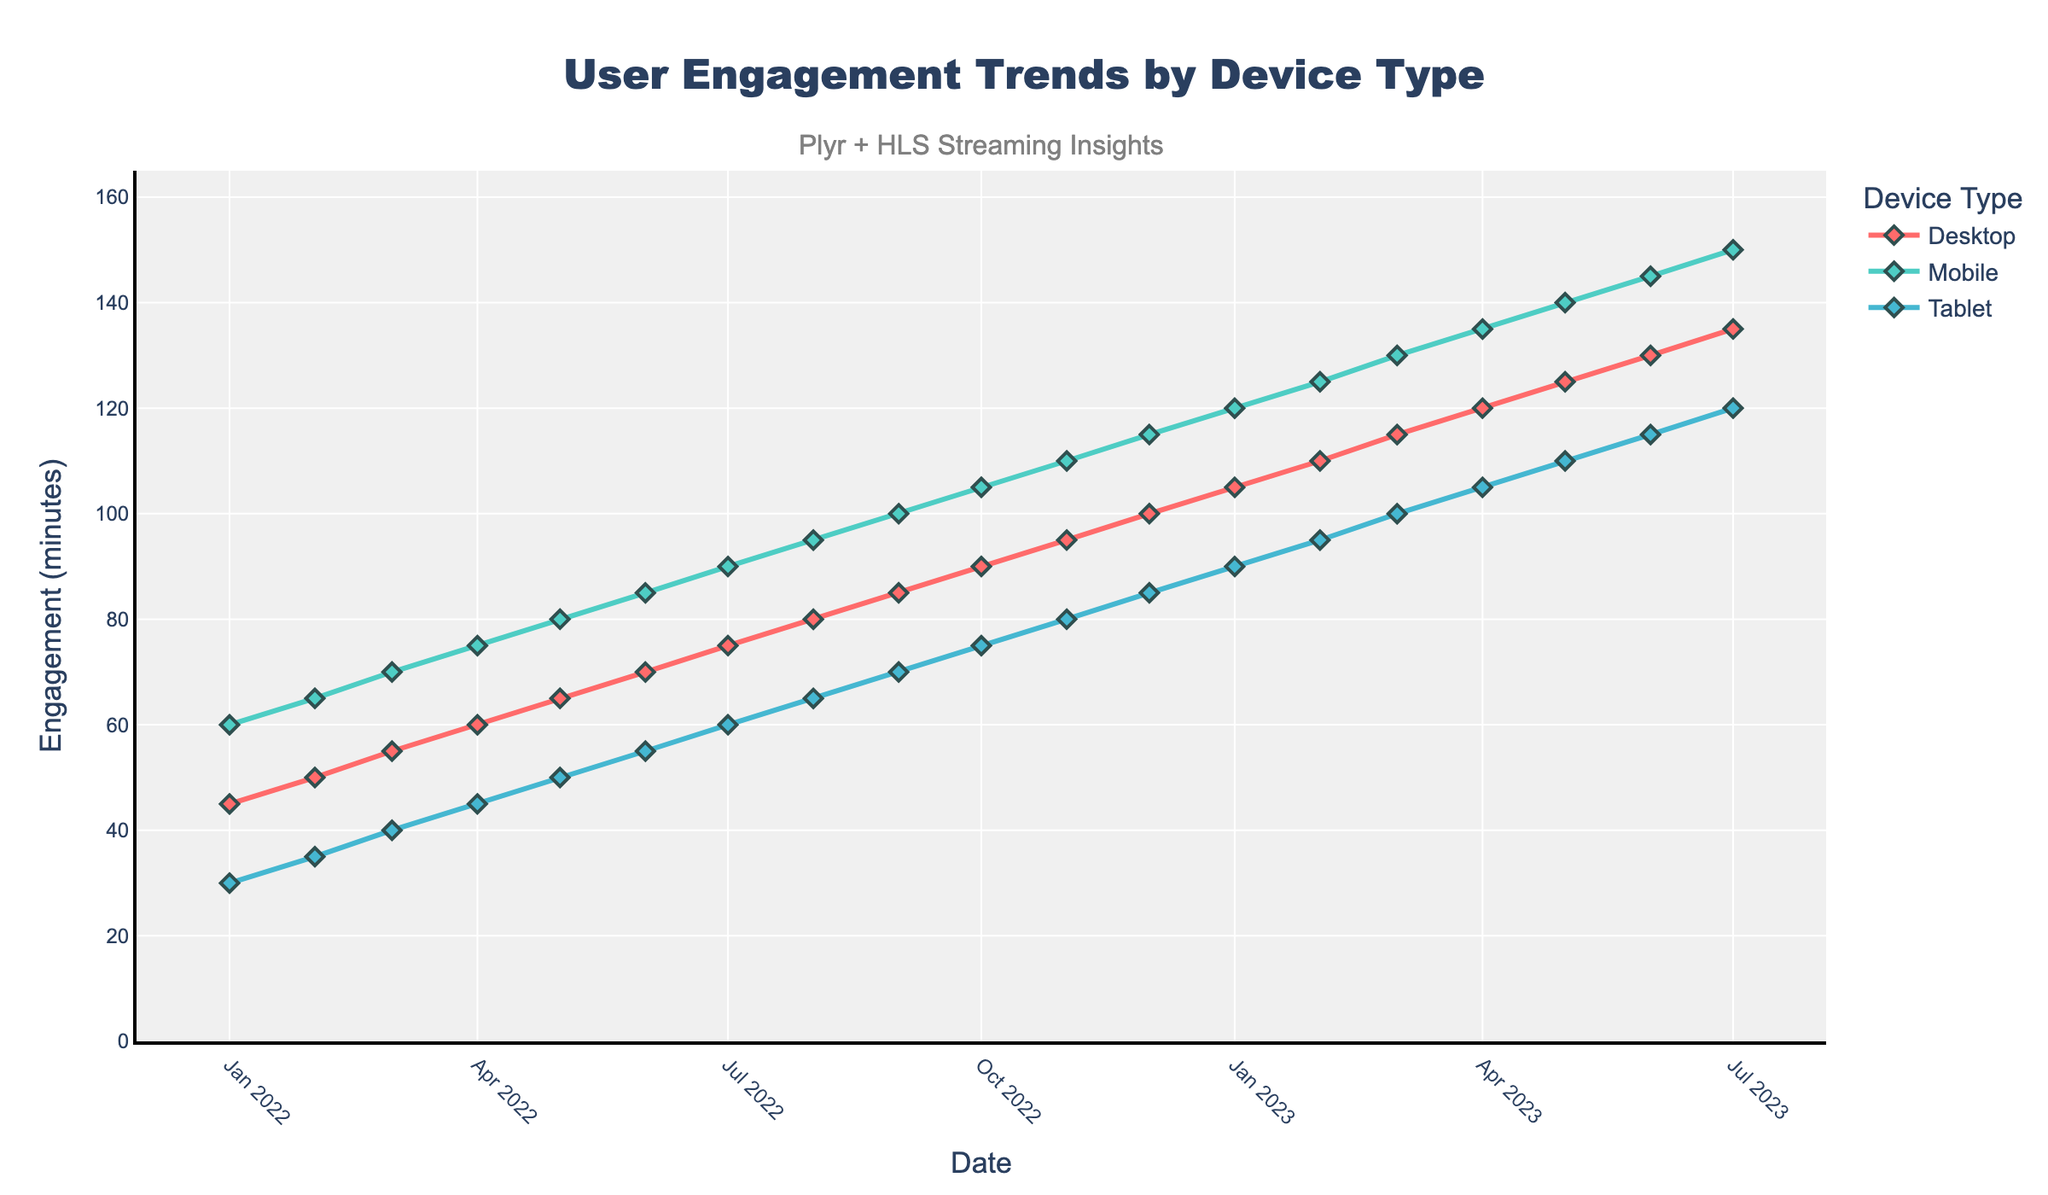What is the title of the plot? The title is displayed at the top of the plot in large, bold text. According to the title section, it reads: 'User Engagement Trends by Device Type'.
Answer: User Engagement Trends by Device Type What does the y-axis represent? The label on the y-axis states 'Engagement (minutes)', indicating that it measures engagement in minutes.
Answer: Engagement (minutes) Which device type shows the highest engagement in July 2023? By looking at the data points for July 2023, the green line representing the mobile device shows the highest engagement, stacking at around 150 minutes.
Answer: Mobile How does the engagement trend for 'tablet' change from January 2022 to July 2023? From January 2022 to July 2023, the blue line for the tablet steadily increases. It starts at 30 minutes in January 2022 and continuously rises to 120 minutes in July 2023.
Answer: Increases steadily What is the average engagement for desktop devices in the year 2022? Summing up the engagement for desktop devices each month of 2022 (45 + 50 + 55 + 60 + 65 + 70 + 75 + 80 + 85 + 90 + 95 + 100) gives 880 minutes. Dividing this by 12 months, we get an average of 880 / 12 ≈ 73.33 minutes.
Answer: ~73.33 minutes Which device type had the highest increase in engagement from January 2022 to July 2023? By examining the lines, we noted that mobile devices increase from 60 minutes in January 2022 to 150 minutes in July 2023, a total increase of 90 minutes. Comparing this with other devices, the mobile device has the highest increase.
Answer: Mobile What is the engagement trend for mobile devices between June 2022 and December 2022? Observing the green line representing mobile devices, the engagement rises from 85 minutes in June 2022 to 115 minutes in December 2022, indicating a steady upward trend.
Answer: Steady upward trend In what month did 'tablet' engagement surpass 'desktop' engagement for the first time? By tracking the blue (tablet) and red (desktop) lines, we see that in February 2023, the tablet engagement (95 minutes) overtook desktop engagement (90 minutes).
Answer: February 2023 How much higher was the engagement for mobile devices compared to tablet devices in October 2022? The engagement in October 2022 for mobile devices is 105 minutes, while for tablet devices it is 75 minutes. The difference is 105 - 75 = 30 minutes.
Answer: 30 minutes What annotations are added to the plot? There is an annotation at the top center above the main title, which reads 'Plyr + HLS Streaming Insights' in gray font.
Answer: Plyr + HLS Streaming Insights 